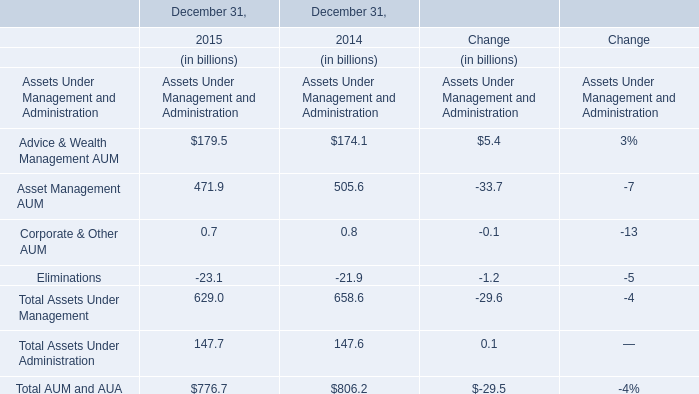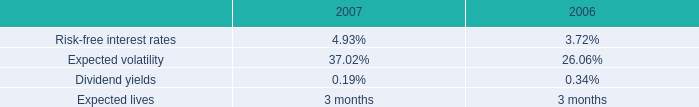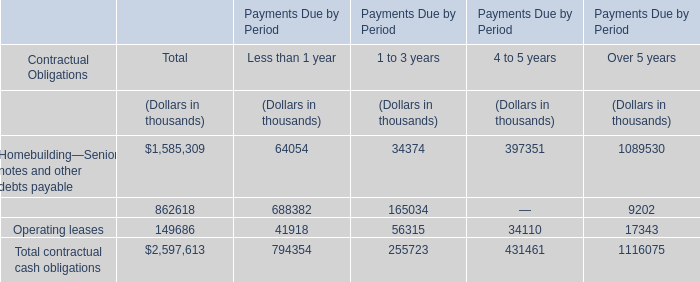What's the growth rate of Asset Management AUM in 2015? 
Computations: ((471.9 - 505.6) / 505.6)
Answer: -0.06665. 